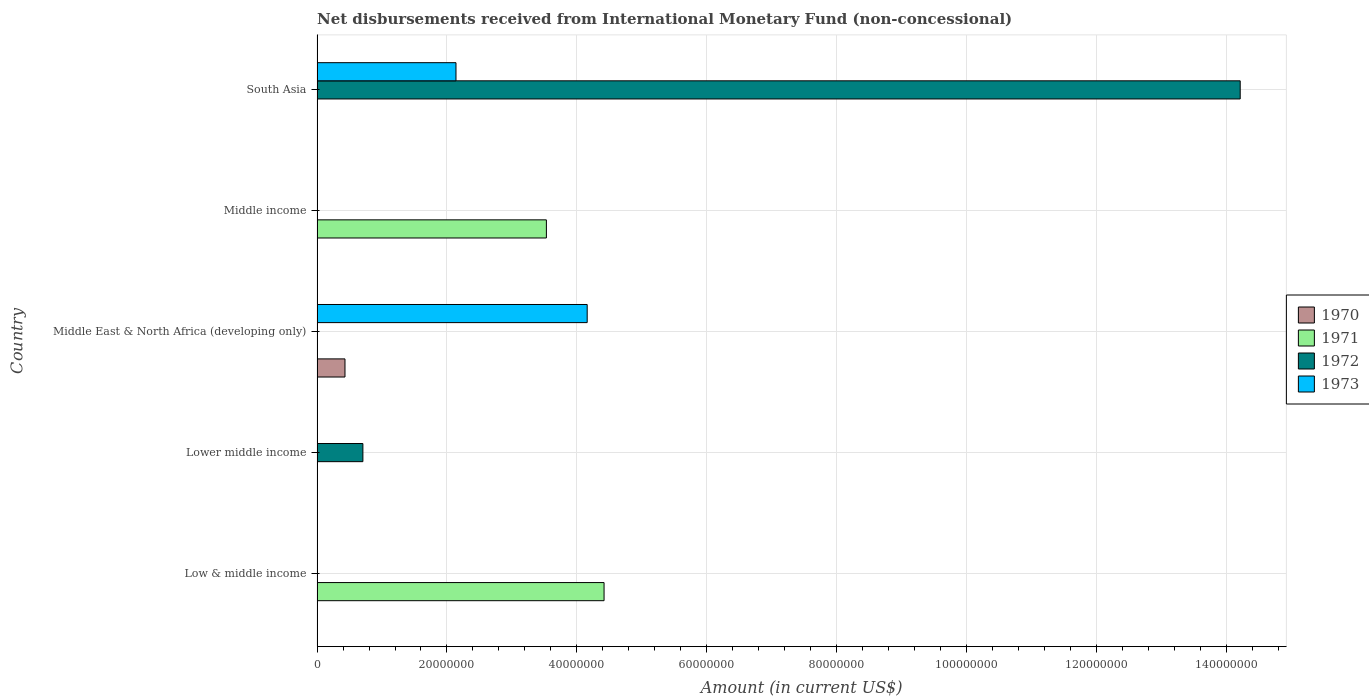How many bars are there on the 3rd tick from the top?
Make the answer very short. 2. How many bars are there on the 2nd tick from the bottom?
Provide a succinct answer. 1. What is the label of the 5th group of bars from the top?
Offer a terse response. Low & middle income. In how many cases, is the number of bars for a given country not equal to the number of legend labels?
Keep it short and to the point. 5. What is the amount of disbursements received from International Monetary Fund in 1973 in South Asia?
Provide a succinct answer. 2.14e+07. Across all countries, what is the maximum amount of disbursements received from International Monetary Fund in 1970?
Offer a terse response. 4.30e+06. Across all countries, what is the minimum amount of disbursements received from International Monetary Fund in 1973?
Your answer should be very brief. 0. In which country was the amount of disbursements received from International Monetary Fund in 1972 maximum?
Offer a very short reply. South Asia. What is the total amount of disbursements received from International Monetary Fund in 1971 in the graph?
Keep it short and to the point. 7.95e+07. What is the difference between the amount of disbursements received from International Monetary Fund in 1973 in Middle East & North Africa (developing only) and that in South Asia?
Offer a terse response. 2.02e+07. What is the difference between the amount of disbursements received from International Monetary Fund in 1973 in South Asia and the amount of disbursements received from International Monetary Fund in 1971 in Middle income?
Provide a short and direct response. -1.39e+07. What is the average amount of disbursements received from International Monetary Fund in 1972 per country?
Ensure brevity in your answer.  2.98e+07. What is the difference between the amount of disbursements received from International Monetary Fund in 1973 and amount of disbursements received from International Monetary Fund in 1972 in South Asia?
Offer a terse response. -1.21e+08. What is the ratio of the amount of disbursements received from International Monetary Fund in 1973 in Middle East & North Africa (developing only) to that in South Asia?
Provide a short and direct response. 1.94. What is the difference between the highest and the lowest amount of disbursements received from International Monetary Fund in 1970?
Keep it short and to the point. 4.30e+06. Is it the case that in every country, the sum of the amount of disbursements received from International Monetary Fund in 1970 and amount of disbursements received from International Monetary Fund in 1971 is greater than the amount of disbursements received from International Monetary Fund in 1972?
Offer a terse response. No. How many bars are there?
Make the answer very short. 7. Are all the bars in the graph horizontal?
Keep it short and to the point. Yes. How many countries are there in the graph?
Your answer should be very brief. 5. Does the graph contain grids?
Offer a very short reply. Yes. How many legend labels are there?
Provide a short and direct response. 4. How are the legend labels stacked?
Your answer should be compact. Vertical. What is the title of the graph?
Your answer should be compact. Net disbursements received from International Monetary Fund (non-concessional). Does "2008" appear as one of the legend labels in the graph?
Offer a terse response. No. What is the label or title of the X-axis?
Ensure brevity in your answer.  Amount (in current US$). What is the Amount (in current US$) in 1970 in Low & middle income?
Keep it short and to the point. 0. What is the Amount (in current US$) of 1971 in Low & middle income?
Make the answer very short. 4.42e+07. What is the Amount (in current US$) in 1972 in Low & middle income?
Your answer should be very brief. 0. What is the Amount (in current US$) of 1973 in Low & middle income?
Keep it short and to the point. 0. What is the Amount (in current US$) of 1971 in Lower middle income?
Keep it short and to the point. 0. What is the Amount (in current US$) of 1972 in Lower middle income?
Your answer should be compact. 7.06e+06. What is the Amount (in current US$) of 1970 in Middle East & North Africa (developing only)?
Provide a short and direct response. 4.30e+06. What is the Amount (in current US$) in 1971 in Middle East & North Africa (developing only)?
Keep it short and to the point. 0. What is the Amount (in current US$) in 1972 in Middle East & North Africa (developing only)?
Give a very brief answer. 0. What is the Amount (in current US$) in 1973 in Middle East & North Africa (developing only)?
Provide a short and direct response. 4.16e+07. What is the Amount (in current US$) of 1971 in Middle income?
Provide a short and direct response. 3.53e+07. What is the Amount (in current US$) of 1973 in Middle income?
Keep it short and to the point. 0. What is the Amount (in current US$) in 1970 in South Asia?
Ensure brevity in your answer.  0. What is the Amount (in current US$) in 1971 in South Asia?
Keep it short and to the point. 0. What is the Amount (in current US$) of 1972 in South Asia?
Provide a succinct answer. 1.42e+08. What is the Amount (in current US$) in 1973 in South Asia?
Give a very brief answer. 2.14e+07. Across all countries, what is the maximum Amount (in current US$) of 1970?
Offer a terse response. 4.30e+06. Across all countries, what is the maximum Amount (in current US$) of 1971?
Provide a short and direct response. 4.42e+07. Across all countries, what is the maximum Amount (in current US$) in 1972?
Your answer should be very brief. 1.42e+08. Across all countries, what is the maximum Amount (in current US$) in 1973?
Your response must be concise. 4.16e+07. Across all countries, what is the minimum Amount (in current US$) in 1971?
Your answer should be very brief. 0. Across all countries, what is the minimum Amount (in current US$) in 1973?
Ensure brevity in your answer.  0. What is the total Amount (in current US$) of 1970 in the graph?
Give a very brief answer. 4.30e+06. What is the total Amount (in current US$) of 1971 in the graph?
Provide a succinct answer. 7.95e+07. What is the total Amount (in current US$) in 1972 in the graph?
Ensure brevity in your answer.  1.49e+08. What is the total Amount (in current US$) in 1973 in the graph?
Offer a terse response. 6.30e+07. What is the difference between the Amount (in current US$) in 1971 in Low & middle income and that in Middle income?
Provide a short and direct response. 8.88e+06. What is the difference between the Amount (in current US$) of 1972 in Lower middle income and that in South Asia?
Give a very brief answer. -1.35e+08. What is the difference between the Amount (in current US$) of 1973 in Middle East & North Africa (developing only) and that in South Asia?
Your answer should be compact. 2.02e+07. What is the difference between the Amount (in current US$) of 1971 in Low & middle income and the Amount (in current US$) of 1972 in Lower middle income?
Offer a terse response. 3.71e+07. What is the difference between the Amount (in current US$) of 1971 in Low & middle income and the Amount (in current US$) of 1973 in Middle East & North Africa (developing only)?
Ensure brevity in your answer.  2.60e+06. What is the difference between the Amount (in current US$) in 1971 in Low & middle income and the Amount (in current US$) in 1972 in South Asia?
Offer a very short reply. -9.79e+07. What is the difference between the Amount (in current US$) in 1971 in Low & middle income and the Amount (in current US$) in 1973 in South Asia?
Offer a very short reply. 2.28e+07. What is the difference between the Amount (in current US$) of 1972 in Lower middle income and the Amount (in current US$) of 1973 in Middle East & North Africa (developing only)?
Offer a very short reply. -3.45e+07. What is the difference between the Amount (in current US$) of 1972 in Lower middle income and the Amount (in current US$) of 1973 in South Asia?
Your response must be concise. -1.43e+07. What is the difference between the Amount (in current US$) of 1970 in Middle East & North Africa (developing only) and the Amount (in current US$) of 1971 in Middle income?
Your answer should be very brief. -3.10e+07. What is the difference between the Amount (in current US$) of 1970 in Middle East & North Africa (developing only) and the Amount (in current US$) of 1972 in South Asia?
Offer a very short reply. -1.38e+08. What is the difference between the Amount (in current US$) of 1970 in Middle East & North Africa (developing only) and the Amount (in current US$) of 1973 in South Asia?
Provide a succinct answer. -1.71e+07. What is the difference between the Amount (in current US$) in 1971 in Middle income and the Amount (in current US$) in 1972 in South Asia?
Your answer should be very brief. -1.07e+08. What is the difference between the Amount (in current US$) in 1971 in Middle income and the Amount (in current US$) in 1973 in South Asia?
Provide a short and direct response. 1.39e+07. What is the average Amount (in current US$) in 1970 per country?
Offer a very short reply. 8.60e+05. What is the average Amount (in current US$) of 1971 per country?
Make the answer very short. 1.59e+07. What is the average Amount (in current US$) of 1972 per country?
Offer a terse response. 2.98e+07. What is the average Amount (in current US$) of 1973 per country?
Provide a succinct answer. 1.26e+07. What is the difference between the Amount (in current US$) in 1970 and Amount (in current US$) in 1973 in Middle East & North Africa (developing only)?
Keep it short and to the point. -3.73e+07. What is the difference between the Amount (in current US$) in 1972 and Amount (in current US$) in 1973 in South Asia?
Keep it short and to the point. 1.21e+08. What is the ratio of the Amount (in current US$) of 1971 in Low & middle income to that in Middle income?
Offer a terse response. 1.25. What is the ratio of the Amount (in current US$) of 1972 in Lower middle income to that in South Asia?
Make the answer very short. 0.05. What is the ratio of the Amount (in current US$) in 1973 in Middle East & North Africa (developing only) to that in South Asia?
Your answer should be compact. 1.94. What is the difference between the highest and the lowest Amount (in current US$) in 1970?
Keep it short and to the point. 4.30e+06. What is the difference between the highest and the lowest Amount (in current US$) in 1971?
Your response must be concise. 4.42e+07. What is the difference between the highest and the lowest Amount (in current US$) in 1972?
Ensure brevity in your answer.  1.42e+08. What is the difference between the highest and the lowest Amount (in current US$) of 1973?
Provide a succinct answer. 4.16e+07. 